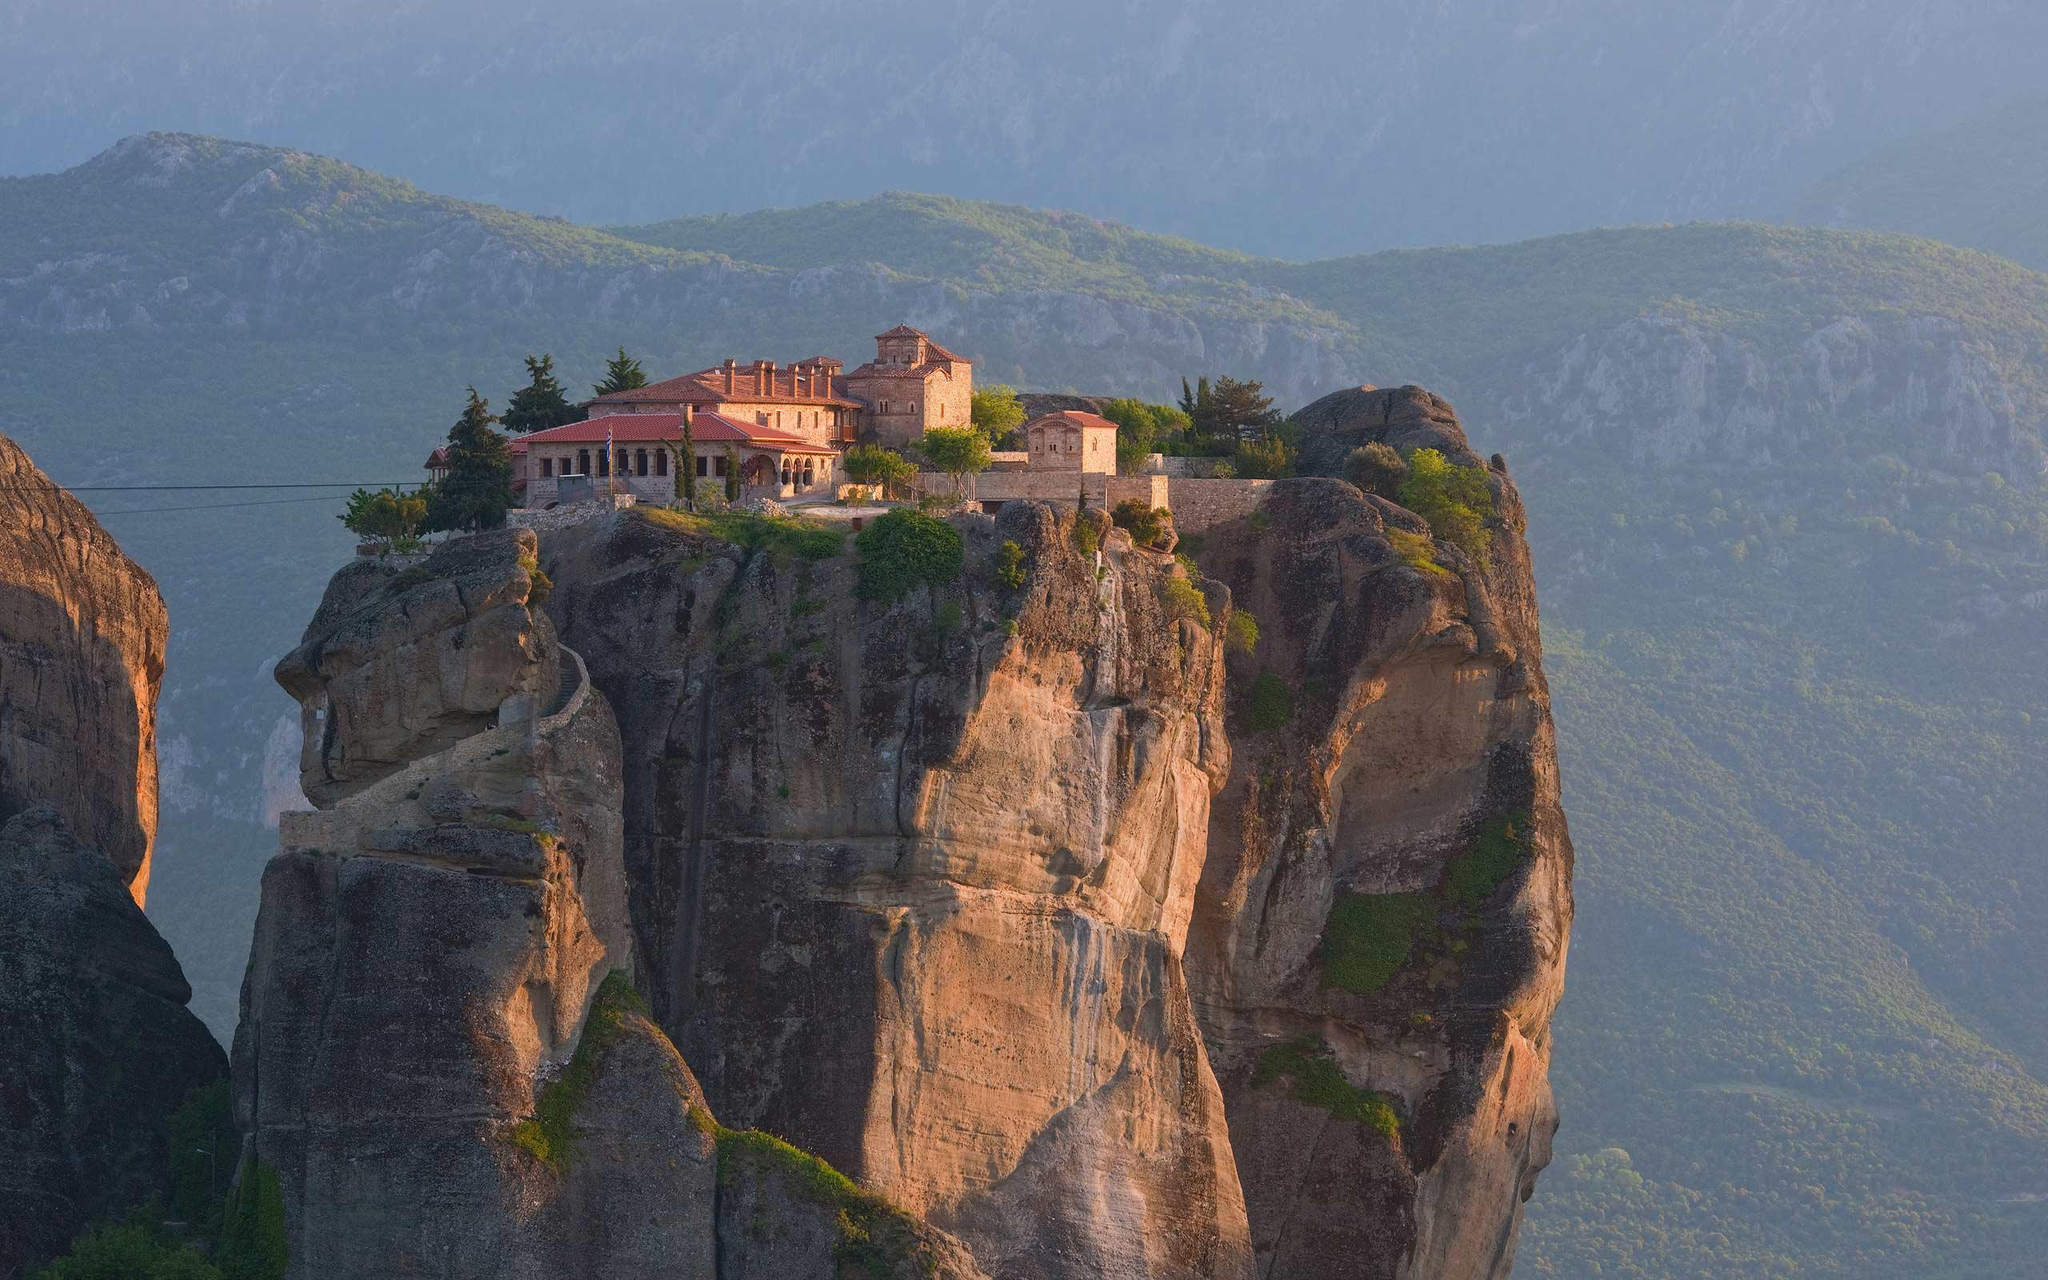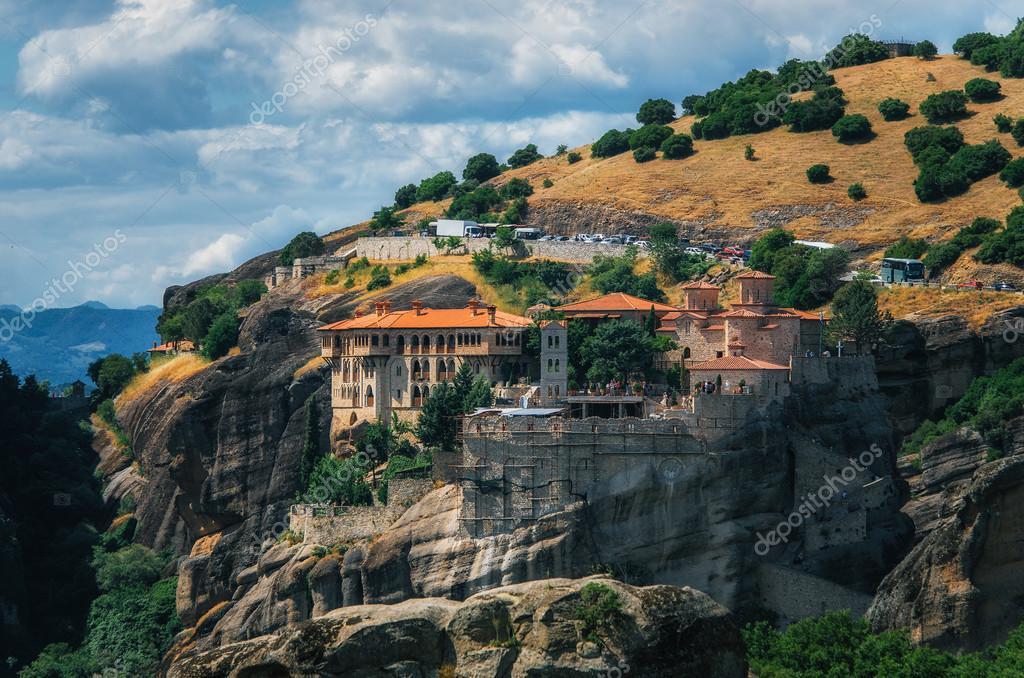The first image is the image on the left, the second image is the image on the right. Assess this claim about the two images: "Both images show a sky above the buildings on the cliffs.". Correct or not? Answer yes or no. Yes. 